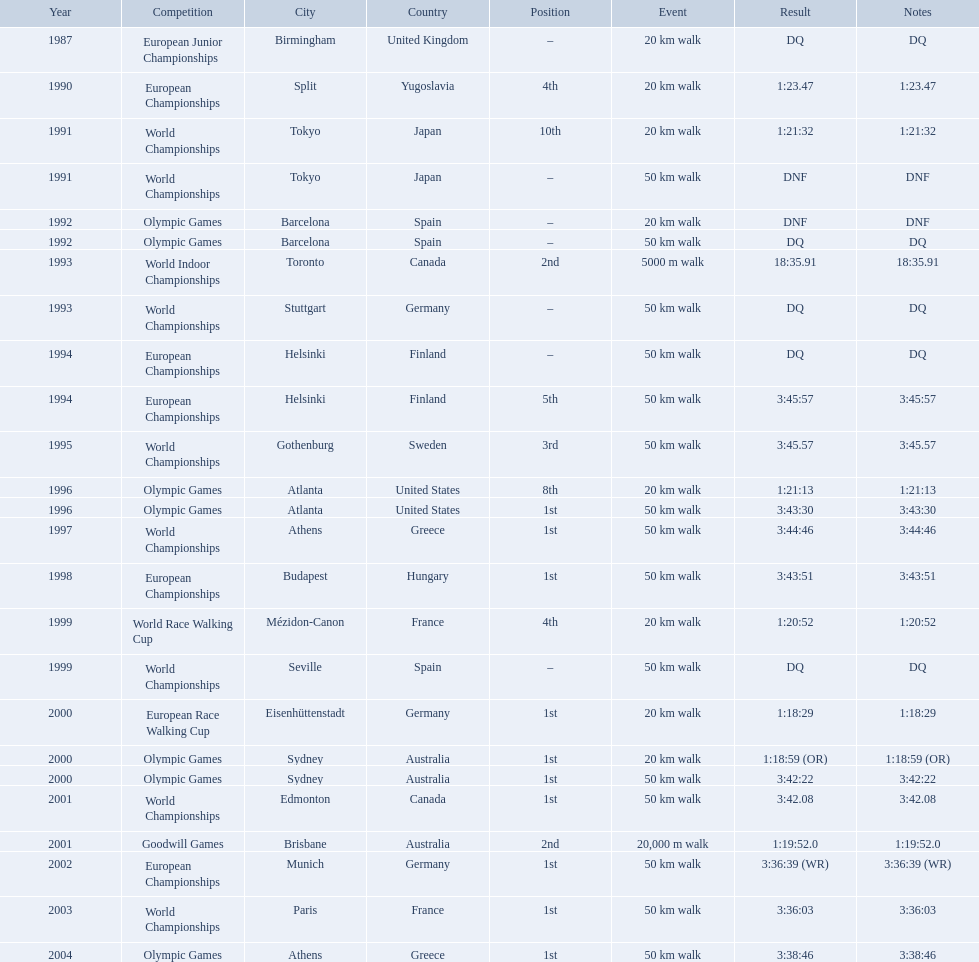What are the notes DQ, 1:23.47, 1:21:32, DNF, DNF, DQ, 18:35.91, DQ, DQ, 3:45:57, 3:45.57, 1:21:13, 3:43:30, 3:44:46, 3:43:51, 1:20:52, DQ, 1:18:29, 1:18:59 (OR), 3:42:22, 3:42.08, 1:19:52.0, 3:36:39 (WR), 3:36:03, 3:38:46. What time does the notes for 2004 show 3:38:46. 